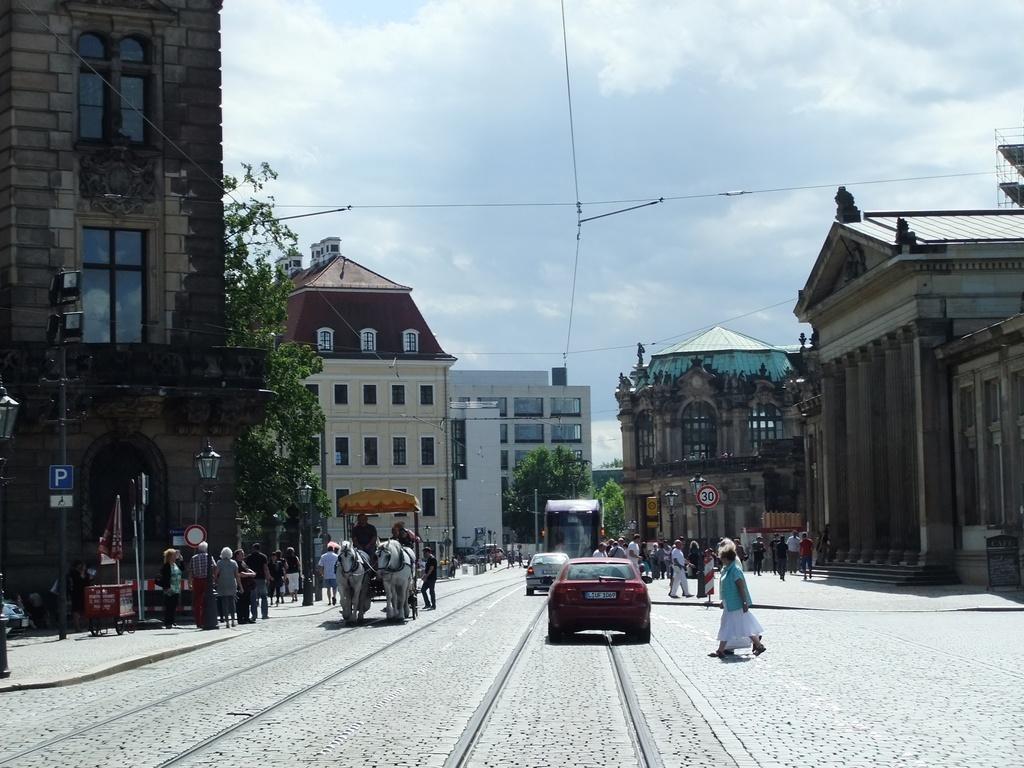Describe this image in one or two sentences. In this image, I can see a horse cart, cars and a bus are moving on the road. I can see groups of people walking. I think these are the streetlights. These are the sign boards attached to the poles. These are the buildings with windows and pillars. I can see the trees. 